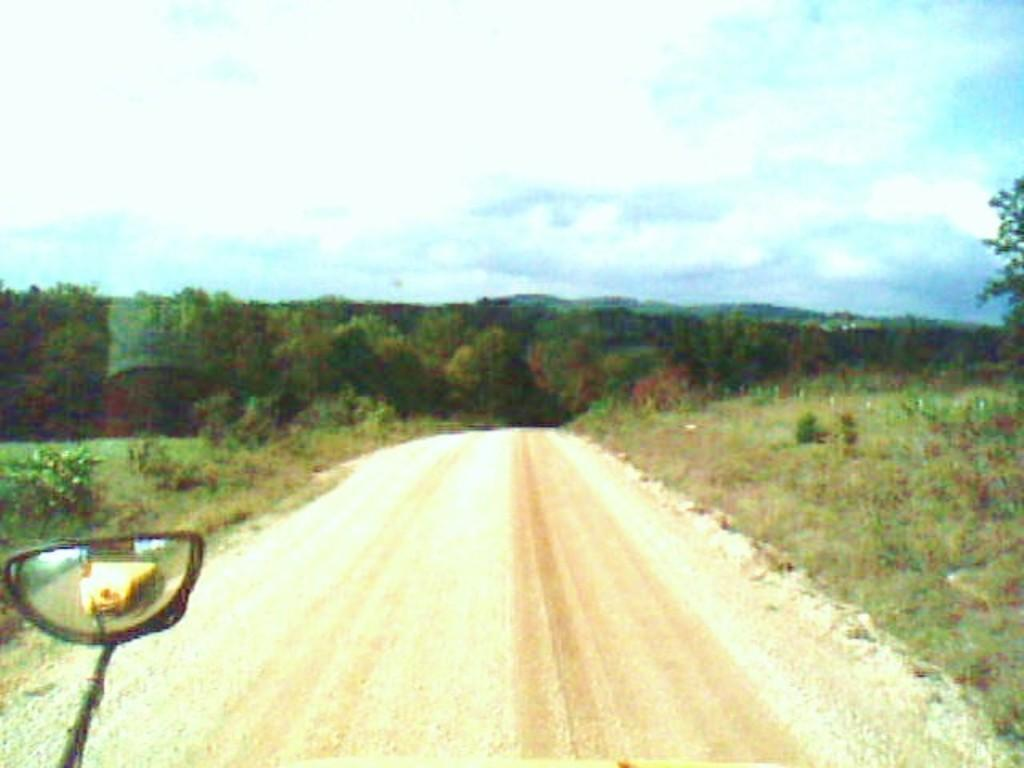What type of vegetation can be seen in the image? There are trees and plants in the image. What covers the ground in the image? There is grass on the ground in the image. Where is the vehicle's side mirror located in the image? The vehicle's side mirror is at the bottom left corner of the image. What is the condition of the sky in the image? The sky is cloudy in the image. Can you see the foot of the person who took the picture in the image? There is no foot visible in the image, as it only features trees, plants, grass, a vehicle's side mirror, and a cloudy sky. What type of pump is being used to water the plants in the image? There is no pump present in the image; it only shows trees, plants, grass, a vehicle's side mirror, and a cloudy sky. 